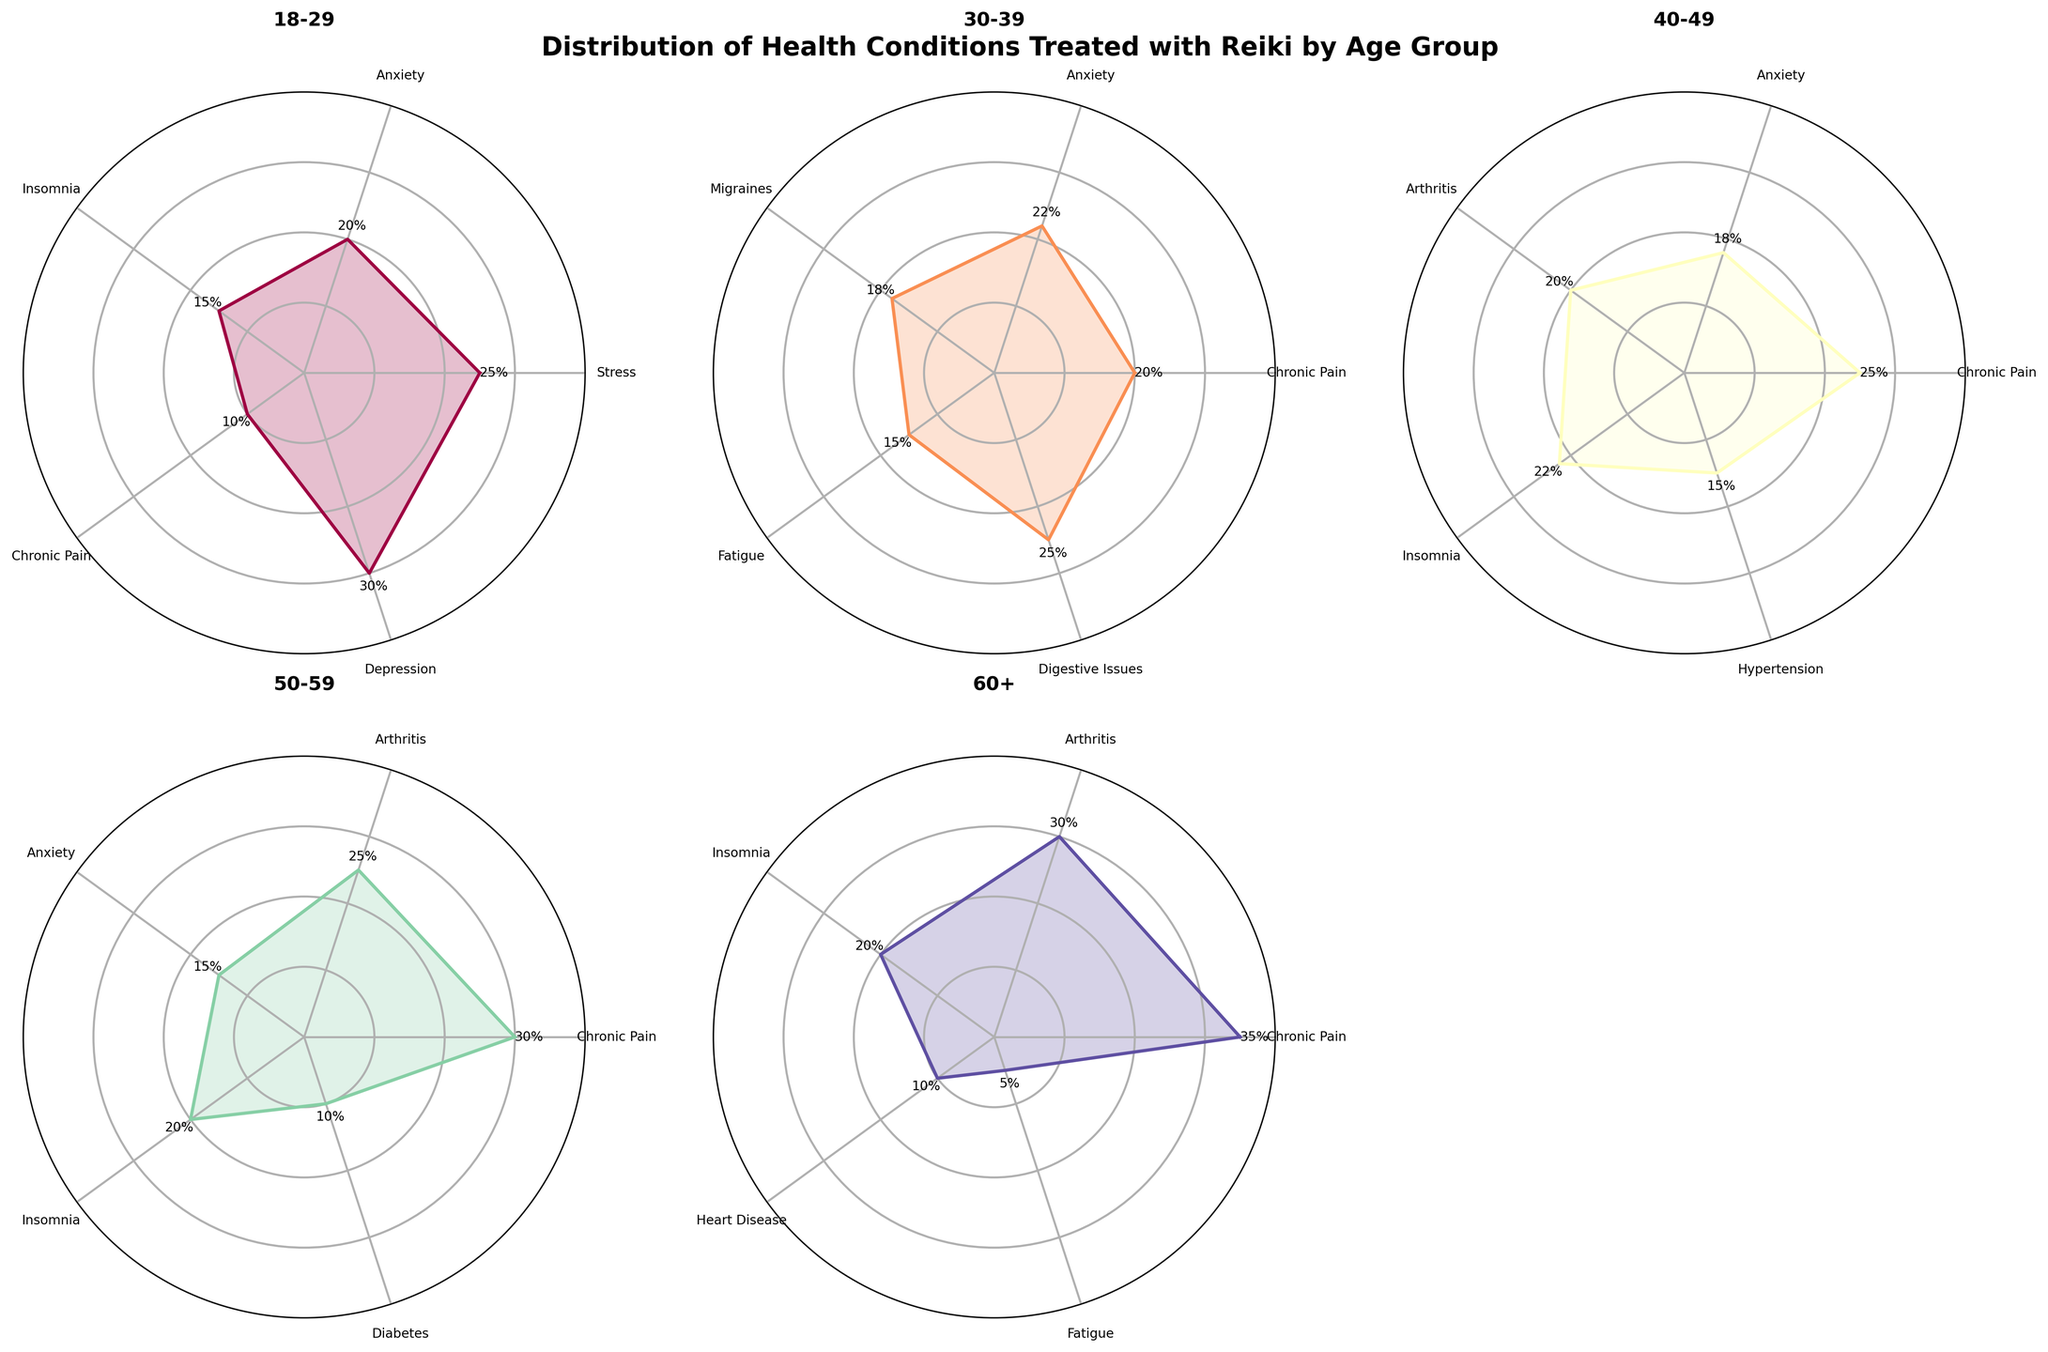What age group has the highest percentage of treating chronic pain with Reiki? Analyzing the rose charts, the age group 60+ has the highest percentage for treating chronic pain, with a value of 35%.
Answer: 60+ Which condition is treated the most for the 18–29 age group? In the 18–29 age group's chart, the highest percentage corresponds to Depression at 30%.
Answer: Depression How does the percentage of anxiety treatment vary across different age groups? By examining each age group's chart, the percentages for treating anxiety are: 18-29 (20%), 30-39 (22%), 40-49 (18%), and 50-59 (15%). Anxiety treatment is not significant for the 60+ group. Therefore, it fluctuates slightly but generally decreases with age.
Answer: It generally decreases with age Which age group treats stress the most with Reiki? The only age group that has stress listed is the 18-29 group with a treatment percentage of 25%. No other age group reports treating stress.
Answer: 18-29 Comparing chronic pain treatments, which age group treats it the least? The rose charts indicate that the 18-29 age group treats chronic pain the least with a percentage of 10%.
Answer: 18-29 What is the most treated condition for the age group 50-59? The most treated condition for the 50-59 age group, as seen in their chart, is Chronic Pain at 30%.
Answer: Chronic Pain How many conditions are treated with Reiki in the 40-49 age group? The 40-49 age group's chart lists five conditions: Chronic Pain, Anxiety, Arthritis, Insomnia, and Hypertension.
Answer: 5 For which condition does the 60+ age group have the second highest percentage of treatment? In the chart for the 60+ age group, Arthritis is the condition with the second highest treatment percentage at 30%.
Answer: Arthritis Which age group has the most varied conditions treated with Reiki? By counting the different conditions in each rose chart, the 30-39 age group treats five different conditions: Chronic Pain, Anxiety, Migraines, Fatigue, and Digestive Issues.
Answer: 30-39 What is the average percentage of treating insomnia across all age groups? The percentages for treating insomnia in each age group's chart are 15%, 22%, 20%, and 20%. The sum is 77%, giving an average of 77/4 = 19.25%.
Answer: 19.25% 